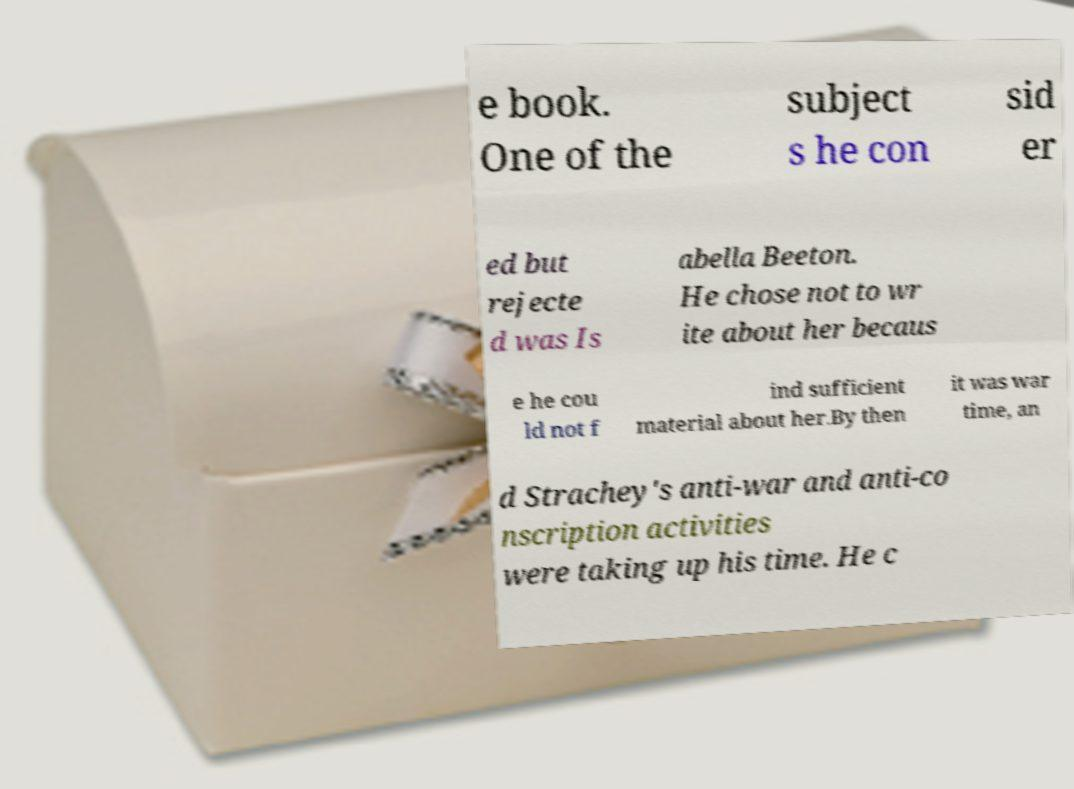For documentation purposes, I need the text within this image transcribed. Could you provide that? e book. One of the subject s he con sid er ed but rejecte d was Is abella Beeton. He chose not to wr ite about her becaus e he cou ld not f ind sufficient material about her.By then it was war time, an d Strachey's anti-war and anti-co nscription activities were taking up his time. He c 